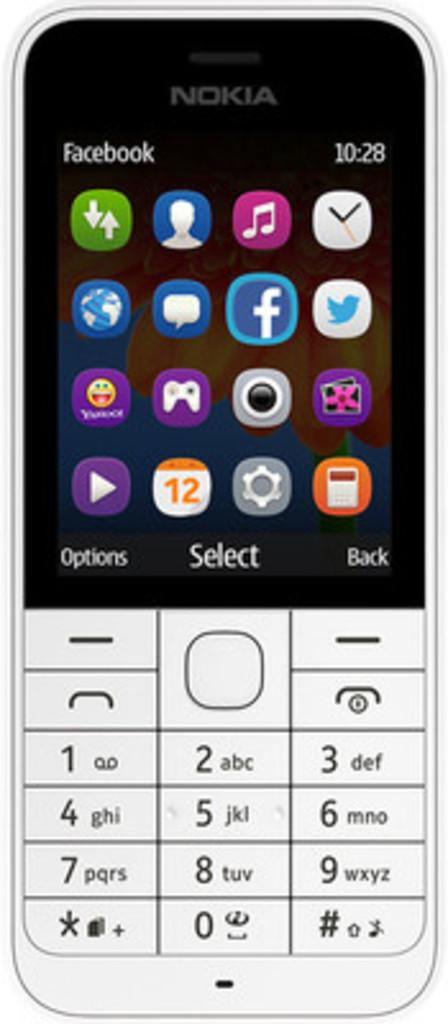<image>
Give a short and clear explanation of the subsequent image. The app facebook is written at the top left of this phone. 